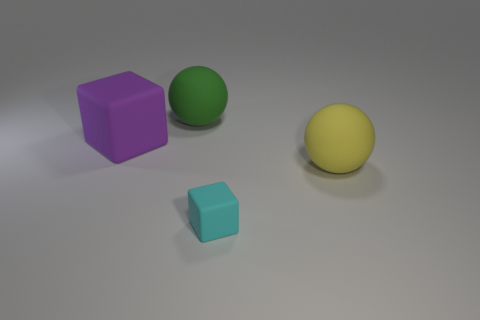Subtract 1 cubes. How many cubes are left? 1 Add 3 large brown metallic cylinders. How many large brown metallic cylinders exist? 3 Add 1 yellow matte spheres. How many objects exist? 5 Subtract 1 purple blocks. How many objects are left? 3 Subtract all blue spheres. Subtract all green blocks. How many spheres are left? 2 Subtract all red cylinders. How many cyan balls are left? 0 Subtract all large green spheres. Subtract all yellow balls. How many objects are left? 2 Add 3 tiny cyan rubber blocks. How many tiny cyan rubber blocks are left? 4 